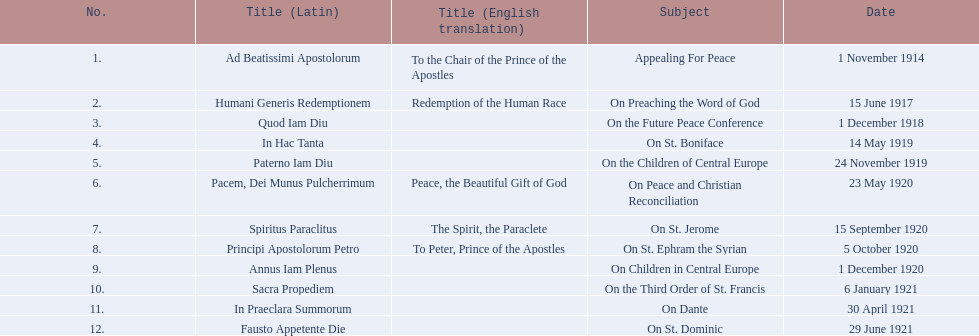What is the only subject on 23 may 1920? On Peace and Christian Reconciliation. 